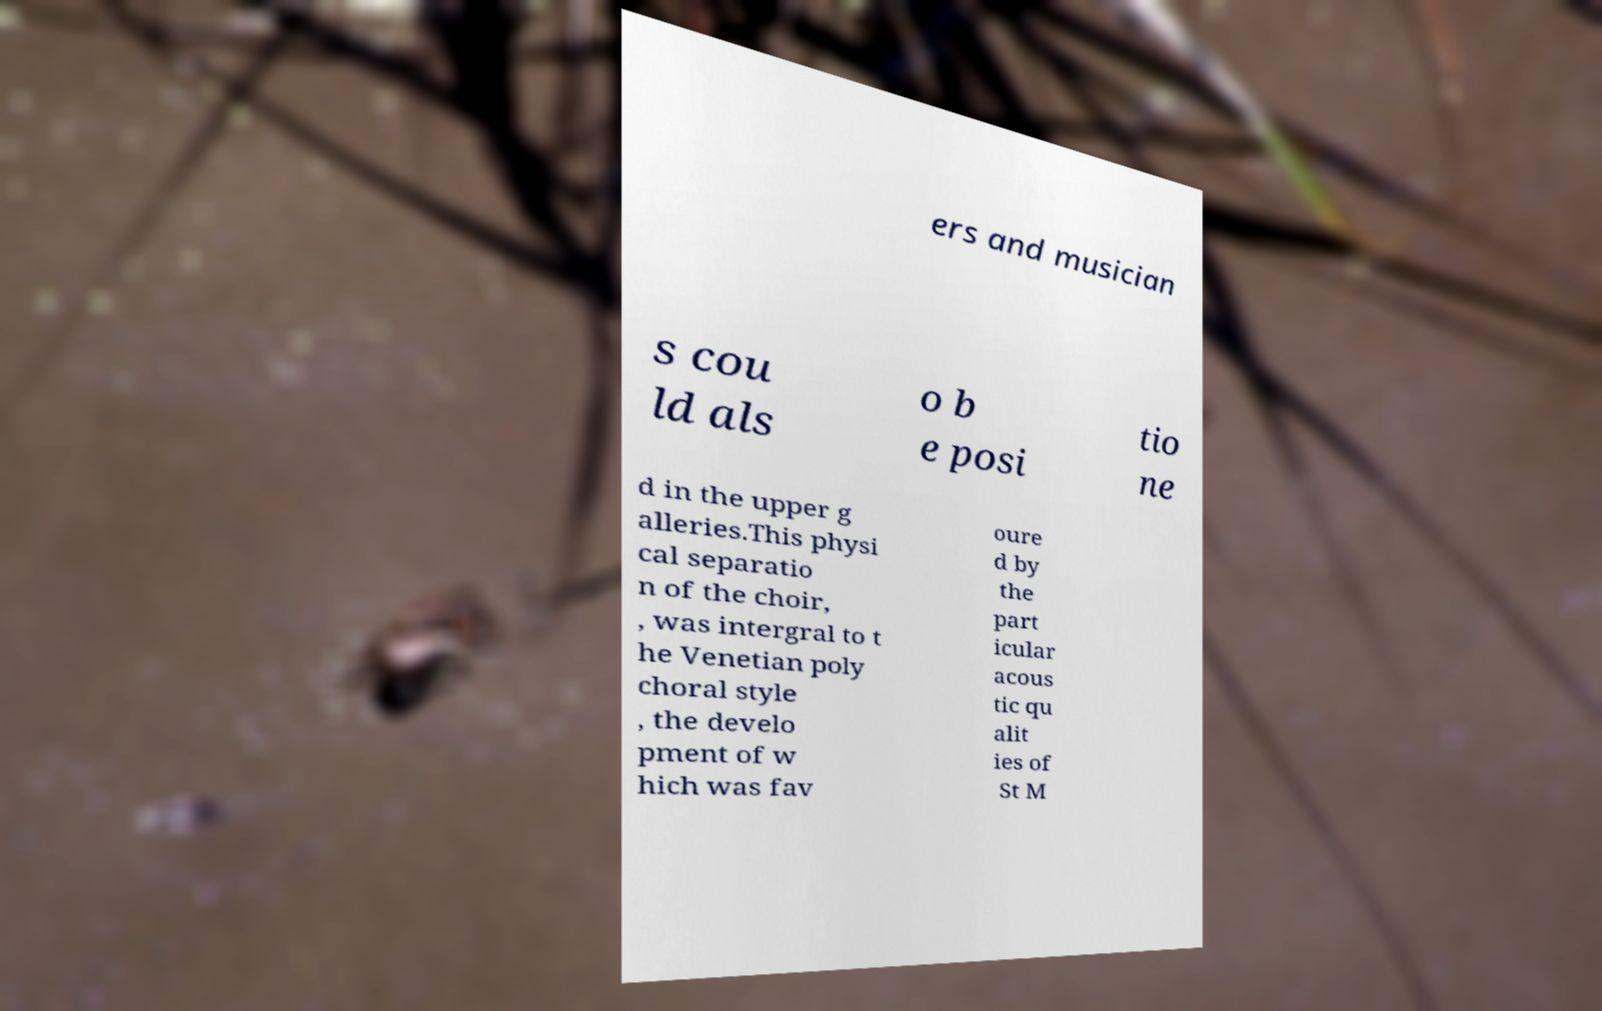Please identify and transcribe the text found in this image. ers and musician s cou ld als o b e posi tio ne d in the upper g alleries.This physi cal separatio n of the choir, , was intergral to t he Venetian poly choral style , the develo pment of w hich was fav oure d by the part icular acous tic qu alit ies of St M 